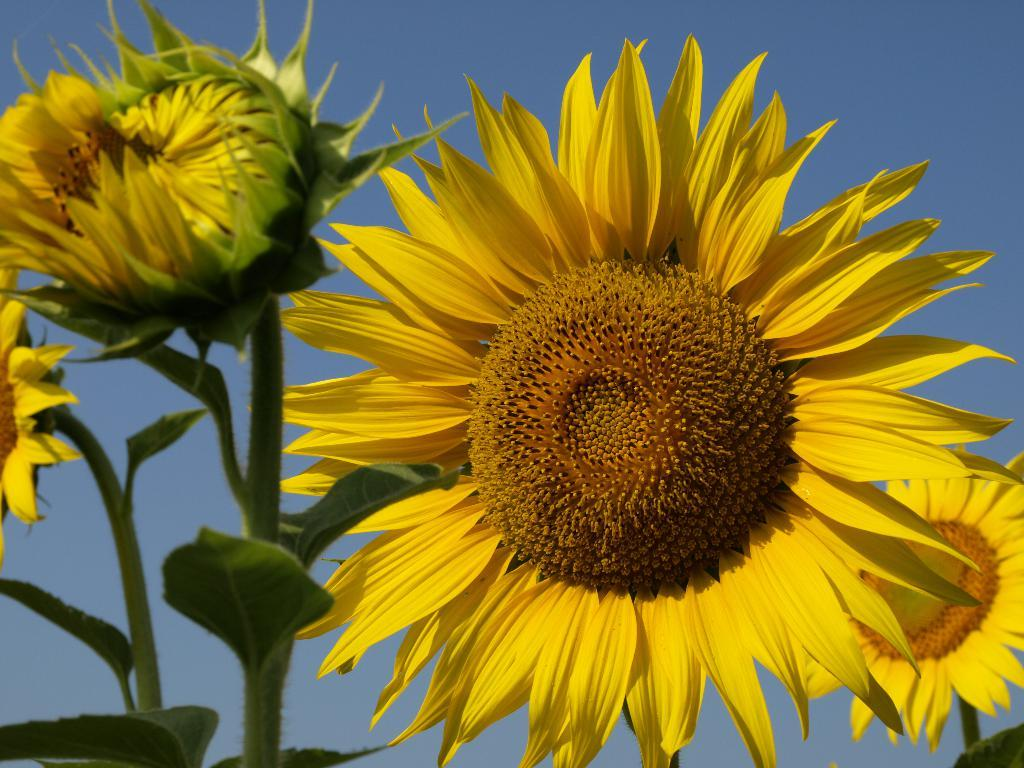What type of flowers are in the image? There are sunflowers in the image. Where are the sunflowers located? The sunflowers are on plants. What is visible at the top of the image? The sky is visible at the top of the image. What type of jeans is the cow wearing in the image? There is no cow or jeans present in the image; it features sunflowers on plants with the sky visible at the top. 